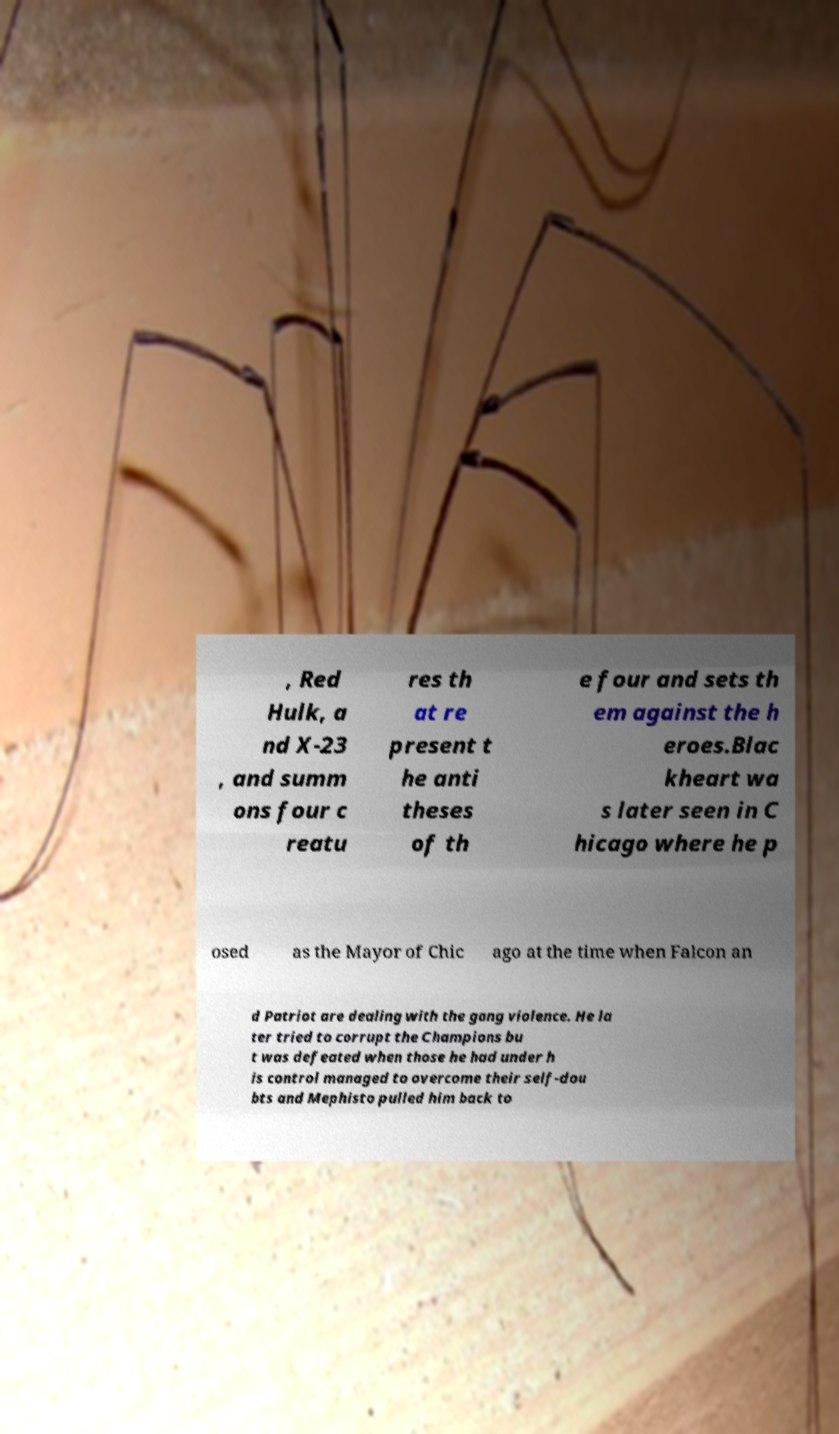What messages or text are displayed in this image? I need them in a readable, typed format. , Red Hulk, a nd X-23 , and summ ons four c reatu res th at re present t he anti theses of th e four and sets th em against the h eroes.Blac kheart wa s later seen in C hicago where he p osed as the Mayor of Chic ago at the time when Falcon an d Patriot are dealing with the gang violence. He la ter tried to corrupt the Champions bu t was defeated when those he had under h is control managed to overcome their self-dou bts and Mephisto pulled him back to 